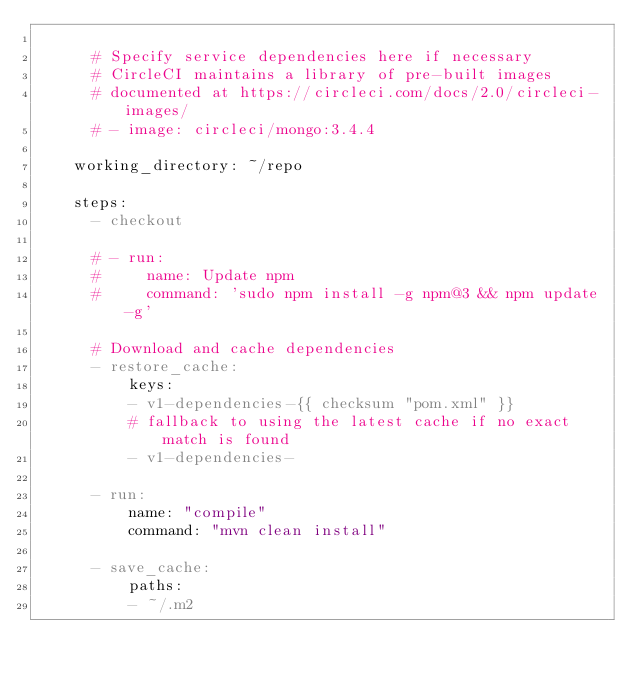<code> <loc_0><loc_0><loc_500><loc_500><_YAML_>
      # Specify service dependencies here if necessary
      # CircleCI maintains a library of pre-built images
      # documented at https://circleci.com/docs/2.0/circleci-images/
      # - image: circleci/mongo:3.4.4

    working_directory: ~/repo

    steps:
      - checkout

      # - run:
      #     name: Update npm
      #     command: 'sudo npm install -g npm@3 && npm update -g'

      # Download and cache dependencies
      - restore_cache:
          keys:
          - v1-dependencies-{{ checksum "pom.xml" }}
          # fallback to using the latest cache if no exact match is found
          - v1-dependencies-

      - run:
          name: "compile"
          command: "mvn clean install"

      - save_cache:
          paths:
          - ~/.m2</code> 